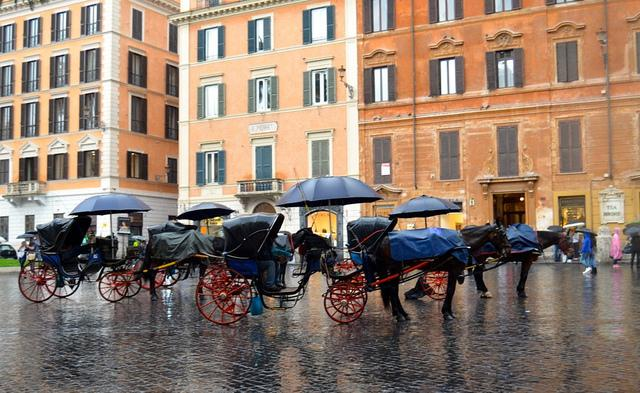What group usually uses this mode of transport? amish 